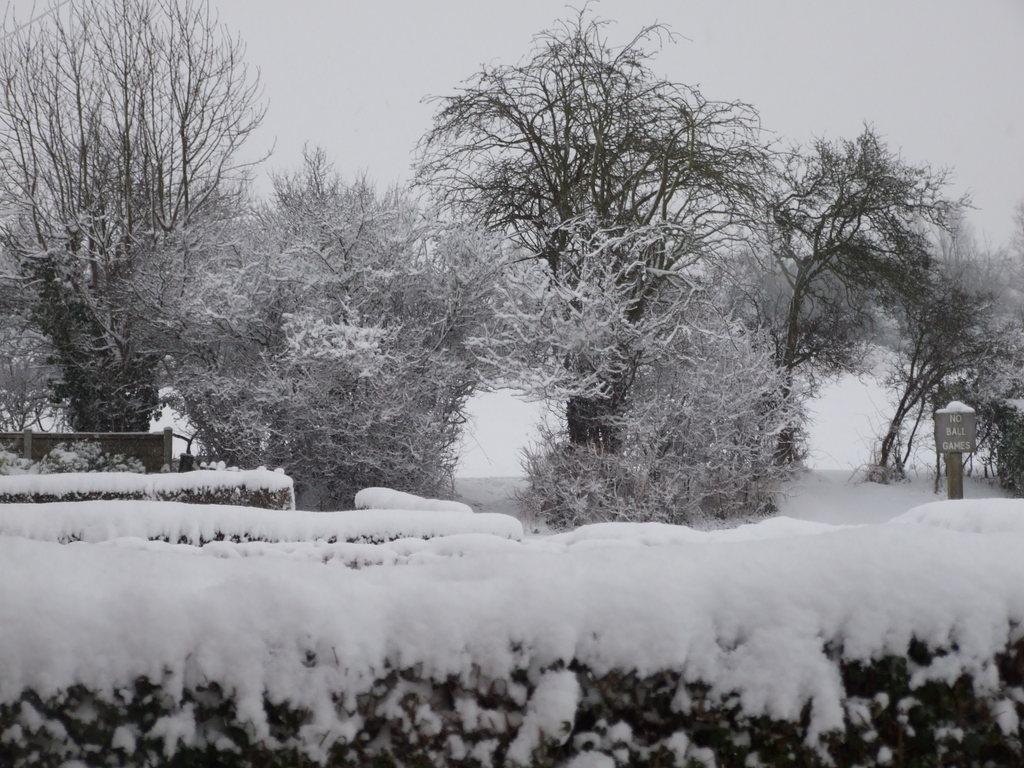What type of vegetation is visible at the top of the image? There are trees at the top side of the image. What is the ground covered with in the image? There is snow around the area of the image. Can you see any ducks swimming in the snow in the image? There are no ducks or any creatures visible in the image; it only features trees and snow. Is there anyone driving a vehicle in the image? There is no vehicle or any indication of driving in the image. 